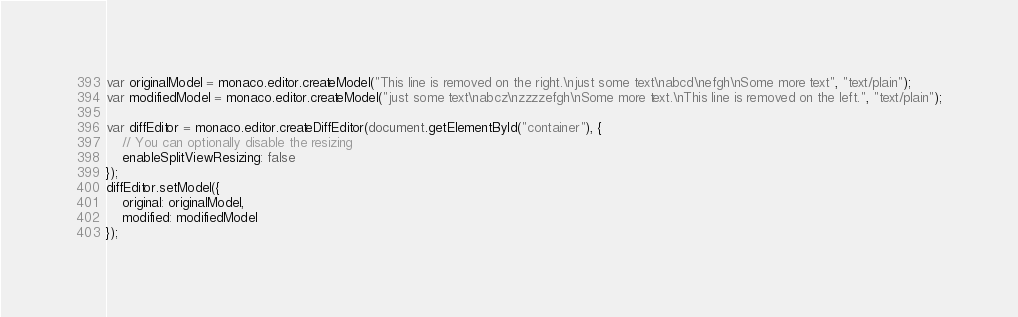Convert code to text. <code><loc_0><loc_0><loc_500><loc_500><_JavaScript_>var originalModel = monaco.editor.createModel("This line is removed on the right.\njust some text\nabcd\nefgh\nSome more text", "text/plain");
var modifiedModel = monaco.editor.createModel("just some text\nabcz\nzzzzefgh\nSome more text.\nThis line is removed on the left.", "text/plain");

var diffEditor = monaco.editor.createDiffEditor(document.getElementById("container"), {
	// You can optionally disable the resizing
	enableSplitViewResizing: false
});
diffEditor.setModel({
	original: originalModel,
	modified: modifiedModel
});
</code> 